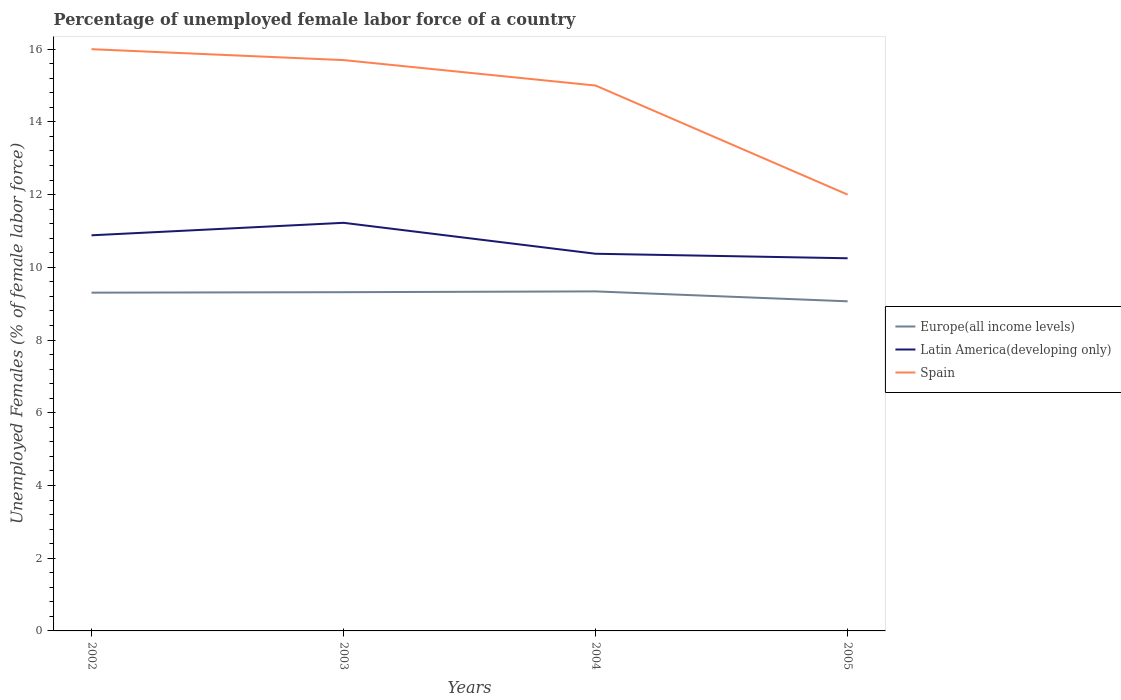How many different coloured lines are there?
Provide a succinct answer. 3. Does the line corresponding to Latin America(developing only) intersect with the line corresponding to Europe(all income levels)?
Offer a terse response. No. Is the number of lines equal to the number of legend labels?
Ensure brevity in your answer.  Yes. Across all years, what is the maximum percentage of unemployed female labor force in Europe(all income levels)?
Give a very brief answer. 9.07. In which year was the percentage of unemployed female labor force in Latin America(developing only) maximum?
Your response must be concise. 2005. What is the total percentage of unemployed female labor force in Europe(all income levels) in the graph?
Give a very brief answer. 0.25. What is the difference between the highest and the lowest percentage of unemployed female labor force in Spain?
Keep it short and to the point. 3. Is the percentage of unemployed female labor force in Europe(all income levels) strictly greater than the percentage of unemployed female labor force in Spain over the years?
Offer a terse response. Yes. How many years are there in the graph?
Give a very brief answer. 4. Are the values on the major ticks of Y-axis written in scientific E-notation?
Ensure brevity in your answer.  No. Does the graph contain any zero values?
Offer a very short reply. No. Does the graph contain grids?
Your response must be concise. No. How are the legend labels stacked?
Your answer should be compact. Vertical. What is the title of the graph?
Ensure brevity in your answer.  Percentage of unemployed female labor force of a country. Does "United Kingdom" appear as one of the legend labels in the graph?
Your answer should be compact. No. What is the label or title of the X-axis?
Ensure brevity in your answer.  Years. What is the label or title of the Y-axis?
Ensure brevity in your answer.  Unemployed Females (% of female labor force). What is the Unemployed Females (% of female labor force) of Europe(all income levels) in 2002?
Offer a terse response. 9.3. What is the Unemployed Females (% of female labor force) in Latin America(developing only) in 2002?
Keep it short and to the point. 10.88. What is the Unemployed Females (% of female labor force) in Europe(all income levels) in 2003?
Provide a succinct answer. 9.32. What is the Unemployed Females (% of female labor force) in Latin America(developing only) in 2003?
Make the answer very short. 11.22. What is the Unemployed Females (% of female labor force) in Spain in 2003?
Your answer should be very brief. 15.7. What is the Unemployed Females (% of female labor force) of Europe(all income levels) in 2004?
Keep it short and to the point. 9.34. What is the Unemployed Females (% of female labor force) of Latin America(developing only) in 2004?
Offer a very short reply. 10.37. What is the Unemployed Females (% of female labor force) of Spain in 2004?
Provide a short and direct response. 15. What is the Unemployed Females (% of female labor force) in Europe(all income levels) in 2005?
Give a very brief answer. 9.07. What is the Unemployed Females (% of female labor force) of Latin America(developing only) in 2005?
Ensure brevity in your answer.  10.25. What is the Unemployed Females (% of female labor force) in Spain in 2005?
Offer a terse response. 12. Across all years, what is the maximum Unemployed Females (% of female labor force) of Europe(all income levels)?
Offer a very short reply. 9.34. Across all years, what is the maximum Unemployed Females (% of female labor force) of Latin America(developing only)?
Your response must be concise. 11.22. Across all years, what is the maximum Unemployed Females (% of female labor force) in Spain?
Provide a short and direct response. 16. Across all years, what is the minimum Unemployed Females (% of female labor force) of Europe(all income levels)?
Your answer should be very brief. 9.07. Across all years, what is the minimum Unemployed Females (% of female labor force) of Latin America(developing only)?
Make the answer very short. 10.25. What is the total Unemployed Females (% of female labor force) in Europe(all income levels) in the graph?
Your response must be concise. 37.02. What is the total Unemployed Females (% of female labor force) in Latin America(developing only) in the graph?
Keep it short and to the point. 42.73. What is the total Unemployed Females (% of female labor force) in Spain in the graph?
Provide a short and direct response. 58.7. What is the difference between the Unemployed Females (% of female labor force) in Europe(all income levels) in 2002 and that in 2003?
Provide a succinct answer. -0.01. What is the difference between the Unemployed Females (% of female labor force) of Latin America(developing only) in 2002 and that in 2003?
Offer a very short reply. -0.34. What is the difference between the Unemployed Females (% of female labor force) of Europe(all income levels) in 2002 and that in 2004?
Give a very brief answer. -0.03. What is the difference between the Unemployed Females (% of female labor force) of Latin America(developing only) in 2002 and that in 2004?
Provide a succinct answer. 0.51. What is the difference between the Unemployed Females (% of female labor force) in Spain in 2002 and that in 2004?
Offer a terse response. 1. What is the difference between the Unemployed Females (% of female labor force) of Europe(all income levels) in 2002 and that in 2005?
Your response must be concise. 0.24. What is the difference between the Unemployed Females (% of female labor force) of Latin America(developing only) in 2002 and that in 2005?
Provide a short and direct response. 0.63. What is the difference between the Unemployed Females (% of female labor force) in Europe(all income levels) in 2003 and that in 2004?
Provide a short and direct response. -0.02. What is the difference between the Unemployed Females (% of female labor force) in Latin America(developing only) in 2003 and that in 2004?
Ensure brevity in your answer.  0.85. What is the difference between the Unemployed Females (% of female labor force) in Spain in 2003 and that in 2004?
Your answer should be very brief. 0.7. What is the difference between the Unemployed Females (% of female labor force) of Europe(all income levels) in 2003 and that in 2005?
Keep it short and to the point. 0.25. What is the difference between the Unemployed Females (% of female labor force) in Europe(all income levels) in 2004 and that in 2005?
Give a very brief answer. 0.27. What is the difference between the Unemployed Females (% of female labor force) in Latin America(developing only) in 2004 and that in 2005?
Keep it short and to the point. 0.12. What is the difference between the Unemployed Females (% of female labor force) of Spain in 2004 and that in 2005?
Provide a short and direct response. 3. What is the difference between the Unemployed Females (% of female labor force) in Europe(all income levels) in 2002 and the Unemployed Females (% of female labor force) in Latin America(developing only) in 2003?
Your response must be concise. -1.92. What is the difference between the Unemployed Females (% of female labor force) of Europe(all income levels) in 2002 and the Unemployed Females (% of female labor force) of Spain in 2003?
Your answer should be compact. -6.4. What is the difference between the Unemployed Females (% of female labor force) in Latin America(developing only) in 2002 and the Unemployed Females (% of female labor force) in Spain in 2003?
Your answer should be very brief. -4.82. What is the difference between the Unemployed Females (% of female labor force) in Europe(all income levels) in 2002 and the Unemployed Females (% of female labor force) in Latin America(developing only) in 2004?
Your answer should be compact. -1.07. What is the difference between the Unemployed Females (% of female labor force) in Europe(all income levels) in 2002 and the Unemployed Females (% of female labor force) in Spain in 2004?
Ensure brevity in your answer.  -5.7. What is the difference between the Unemployed Females (% of female labor force) in Latin America(developing only) in 2002 and the Unemployed Females (% of female labor force) in Spain in 2004?
Your answer should be compact. -4.12. What is the difference between the Unemployed Females (% of female labor force) of Europe(all income levels) in 2002 and the Unemployed Females (% of female labor force) of Latin America(developing only) in 2005?
Provide a succinct answer. -0.95. What is the difference between the Unemployed Females (% of female labor force) of Europe(all income levels) in 2002 and the Unemployed Females (% of female labor force) of Spain in 2005?
Provide a succinct answer. -2.7. What is the difference between the Unemployed Females (% of female labor force) of Latin America(developing only) in 2002 and the Unemployed Females (% of female labor force) of Spain in 2005?
Provide a succinct answer. -1.12. What is the difference between the Unemployed Females (% of female labor force) in Europe(all income levels) in 2003 and the Unemployed Females (% of female labor force) in Latin America(developing only) in 2004?
Provide a short and direct response. -1.06. What is the difference between the Unemployed Females (% of female labor force) in Europe(all income levels) in 2003 and the Unemployed Females (% of female labor force) in Spain in 2004?
Provide a short and direct response. -5.68. What is the difference between the Unemployed Females (% of female labor force) in Latin America(developing only) in 2003 and the Unemployed Females (% of female labor force) in Spain in 2004?
Your answer should be very brief. -3.78. What is the difference between the Unemployed Females (% of female labor force) in Europe(all income levels) in 2003 and the Unemployed Females (% of female labor force) in Latin America(developing only) in 2005?
Make the answer very short. -0.93. What is the difference between the Unemployed Females (% of female labor force) in Europe(all income levels) in 2003 and the Unemployed Females (% of female labor force) in Spain in 2005?
Provide a succinct answer. -2.68. What is the difference between the Unemployed Females (% of female labor force) in Latin America(developing only) in 2003 and the Unemployed Females (% of female labor force) in Spain in 2005?
Offer a very short reply. -0.78. What is the difference between the Unemployed Females (% of female labor force) of Europe(all income levels) in 2004 and the Unemployed Females (% of female labor force) of Latin America(developing only) in 2005?
Your response must be concise. -0.91. What is the difference between the Unemployed Females (% of female labor force) in Europe(all income levels) in 2004 and the Unemployed Females (% of female labor force) in Spain in 2005?
Offer a terse response. -2.66. What is the difference between the Unemployed Females (% of female labor force) of Latin America(developing only) in 2004 and the Unemployed Females (% of female labor force) of Spain in 2005?
Offer a very short reply. -1.63. What is the average Unemployed Females (% of female labor force) of Europe(all income levels) per year?
Your answer should be very brief. 9.26. What is the average Unemployed Females (% of female labor force) of Latin America(developing only) per year?
Give a very brief answer. 10.68. What is the average Unemployed Females (% of female labor force) in Spain per year?
Your answer should be compact. 14.68. In the year 2002, what is the difference between the Unemployed Females (% of female labor force) of Europe(all income levels) and Unemployed Females (% of female labor force) of Latin America(developing only)?
Keep it short and to the point. -1.58. In the year 2002, what is the difference between the Unemployed Females (% of female labor force) of Europe(all income levels) and Unemployed Females (% of female labor force) of Spain?
Provide a succinct answer. -6.7. In the year 2002, what is the difference between the Unemployed Females (% of female labor force) of Latin America(developing only) and Unemployed Females (% of female labor force) of Spain?
Make the answer very short. -5.12. In the year 2003, what is the difference between the Unemployed Females (% of female labor force) in Europe(all income levels) and Unemployed Females (% of female labor force) in Latin America(developing only)?
Provide a short and direct response. -1.91. In the year 2003, what is the difference between the Unemployed Females (% of female labor force) of Europe(all income levels) and Unemployed Females (% of female labor force) of Spain?
Make the answer very short. -6.38. In the year 2003, what is the difference between the Unemployed Females (% of female labor force) in Latin America(developing only) and Unemployed Females (% of female labor force) in Spain?
Your answer should be compact. -4.48. In the year 2004, what is the difference between the Unemployed Females (% of female labor force) of Europe(all income levels) and Unemployed Females (% of female labor force) of Latin America(developing only)?
Your answer should be very brief. -1.03. In the year 2004, what is the difference between the Unemployed Females (% of female labor force) in Europe(all income levels) and Unemployed Females (% of female labor force) in Spain?
Keep it short and to the point. -5.66. In the year 2004, what is the difference between the Unemployed Females (% of female labor force) of Latin America(developing only) and Unemployed Females (% of female labor force) of Spain?
Provide a short and direct response. -4.63. In the year 2005, what is the difference between the Unemployed Females (% of female labor force) in Europe(all income levels) and Unemployed Females (% of female labor force) in Latin America(developing only)?
Provide a succinct answer. -1.18. In the year 2005, what is the difference between the Unemployed Females (% of female labor force) in Europe(all income levels) and Unemployed Females (% of female labor force) in Spain?
Offer a terse response. -2.93. In the year 2005, what is the difference between the Unemployed Females (% of female labor force) of Latin America(developing only) and Unemployed Females (% of female labor force) of Spain?
Your response must be concise. -1.75. What is the ratio of the Unemployed Females (% of female labor force) in Latin America(developing only) in 2002 to that in 2003?
Offer a very short reply. 0.97. What is the ratio of the Unemployed Females (% of female labor force) in Spain in 2002 to that in 2003?
Offer a terse response. 1.02. What is the ratio of the Unemployed Females (% of female labor force) in Latin America(developing only) in 2002 to that in 2004?
Your response must be concise. 1.05. What is the ratio of the Unemployed Females (% of female labor force) in Spain in 2002 to that in 2004?
Your answer should be very brief. 1.07. What is the ratio of the Unemployed Females (% of female labor force) in Europe(all income levels) in 2002 to that in 2005?
Your response must be concise. 1.03. What is the ratio of the Unemployed Females (% of female labor force) of Latin America(developing only) in 2002 to that in 2005?
Give a very brief answer. 1.06. What is the ratio of the Unemployed Females (% of female labor force) of Spain in 2002 to that in 2005?
Keep it short and to the point. 1.33. What is the ratio of the Unemployed Females (% of female labor force) in Europe(all income levels) in 2003 to that in 2004?
Ensure brevity in your answer.  1. What is the ratio of the Unemployed Females (% of female labor force) of Latin America(developing only) in 2003 to that in 2004?
Ensure brevity in your answer.  1.08. What is the ratio of the Unemployed Females (% of female labor force) of Spain in 2003 to that in 2004?
Ensure brevity in your answer.  1.05. What is the ratio of the Unemployed Females (% of female labor force) in Europe(all income levels) in 2003 to that in 2005?
Give a very brief answer. 1.03. What is the ratio of the Unemployed Females (% of female labor force) in Latin America(developing only) in 2003 to that in 2005?
Make the answer very short. 1.1. What is the ratio of the Unemployed Females (% of female labor force) of Spain in 2003 to that in 2005?
Your response must be concise. 1.31. What is the ratio of the Unemployed Females (% of female labor force) of Europe(all income levels) in 2004 to that in 2005?
Provide a short and direct response. 1.03. What is the ratio of the Unemployed Females (% of female labor force) of Latin America(developing only) in 2004 to that in 2005?
Your answer should be compact. 1.01. What is the difference between the highest and the second highest Unemployed Females (% of female labor force) in Europe(all income levels)?
Offer a terse response. 0.02. What is the difference between the highest and the second highest Unemployed Females (% of female labor force) in Latin America(developing only)?
Provide a short and direct response. 0.34. What is the difference between the highest and the lowest Unemployed Females (% of female labor force) in Europe(all income levels)?
Provide a short and direct response. 0.27. What is the difference between the highest and the lowest Unemployed Females (% of female labor force) in Spain?
Ensure brevity in your answer.  4. 